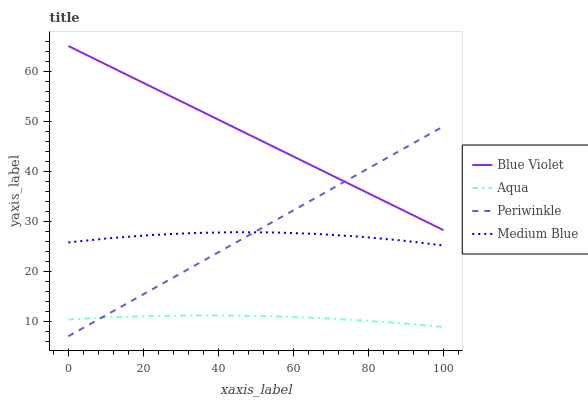Does Aqua have the minimum area under the curve?
Answer yes or no. Yes. Does Blue Violet have the maximum area under the curve?
Answer yes or no. Yes. Does Medium Blue have the minimum area under the curve?
Answer yes or no. No. Does Medium Blue have the maximum area under the curve?
Answer yes or no. No. Is Periwinkle the smoothest?
Answer yes or no. Yes. Is Medium Blue the roughest?
Answer yes or no. Yes. Is Aqua the smoothest?
Answer yes or no. No. Is Aqua the roughest?
Answer yes or no. No. Does Periwinkle have the lowest value?
Answer yes or no. Yes. Does Aqua have the lowest value?
Answer yes or no. No. Does Blue Violet have the highest value?
Answer yes or no. Yes. Does Medium Blue have the highest value?
Answer yes or no. No. Is Medium Blue less than Blue Violet?
Answer yes or no. Yes. Is Blue Violet greater than Medium Blue?
Answer yes or no. Yes. Does Blue Violet intersect Periwinkle?
Answer yes or no. Yes. Is Blue Violet less than Periwinkle?
Answer yes or no. No. Is Blue Violet greater than Periwinkle?
Answer yes or no. No. Does Medium Blue intersect Blue Violet?
Answer yes or no. No. 